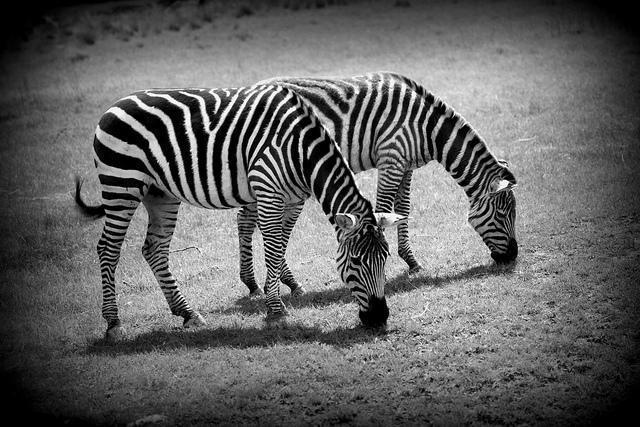How many zebras are there?
Give a very brief answer. 2. How many tails are there?
Give a very brief answer. 1. How many scissors are in blue color?
Give a very brief answer. 0. 